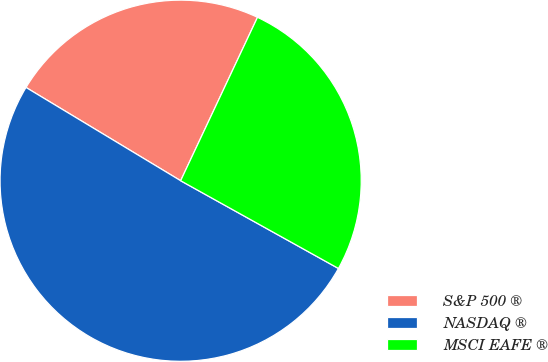Convert chart to OTSL. <chart><loc_0><loc_0><loc_500><loc_500><pie_chart><fcel>S&P 500 ®<fcel>NASDAQ ®<fcel>MSCI EAFE ®<nl><fcel>23.36%<fcel>50.56%<fcel>26.08%<nl></chart> 